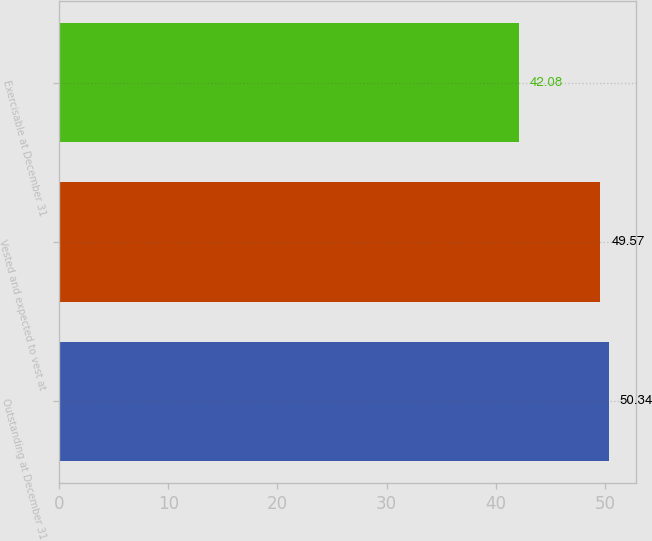Convert chart to OTSL. <chart><loc_0><loc_0><loc_500><loc_500><bar_chart><fcel>Outstanding at December 31<fcel>Vested and expected to vest at<fcel>Exercisable at December 31<nl><fcel>50.34<fcel>49.57<fcel>42.08<nl></chart> 